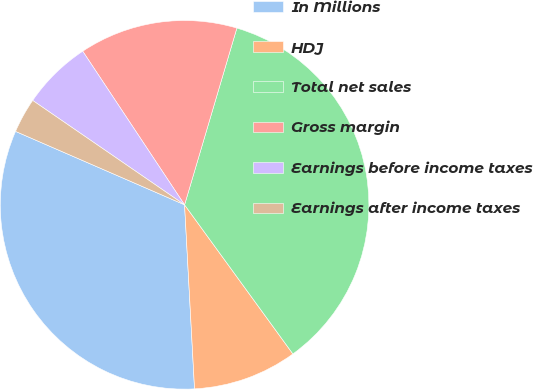Convert chart. <chart><loc_0><loc_0><loc_500><loc_500><pie_chart><fcel>In Millions<fcel>HDJ<fcel>Total net sales<fcel>Gross margin<fcel>Earnings before income taxes<fcel>Earnings after income taxes<nl><fcel>32.39%<fcel>9.14%<fcel>35.43%<fcel>13.9%<fcel>6.1%<fcel>3.06%<nl></chart> 